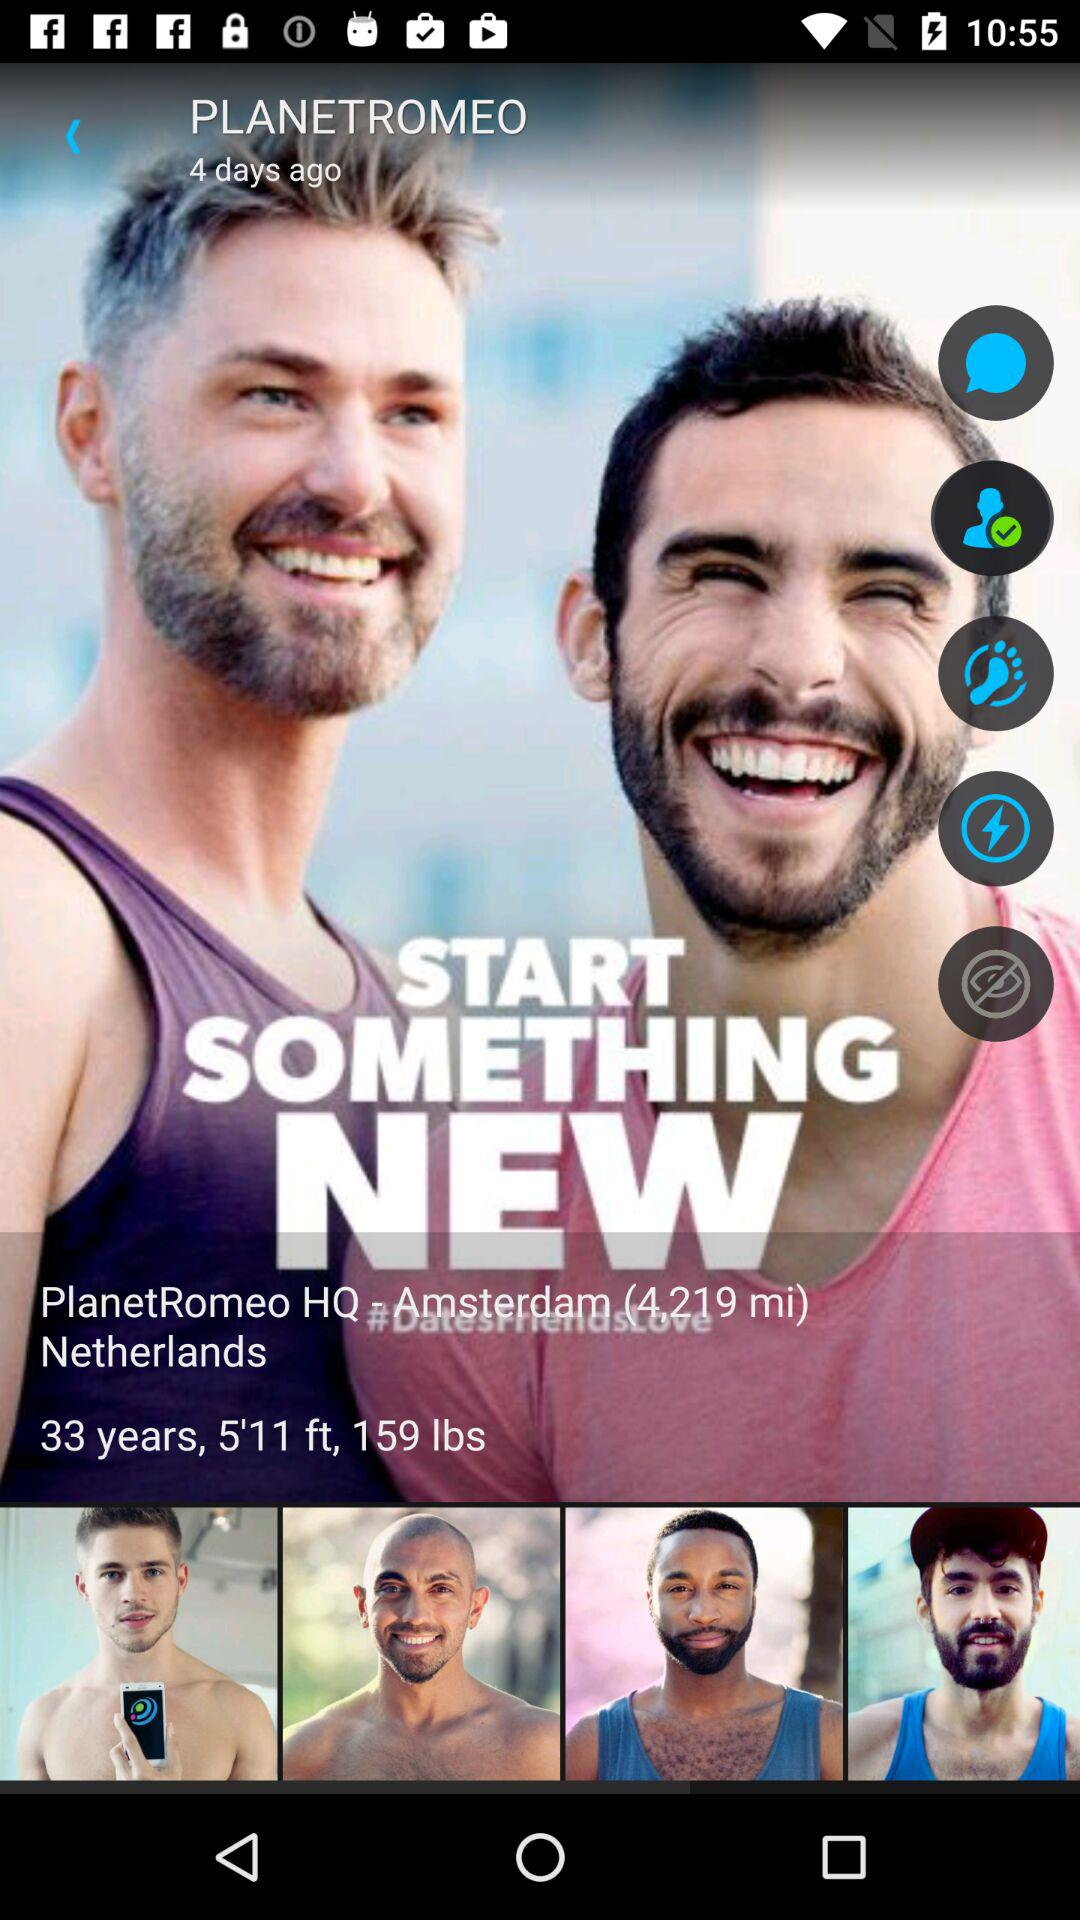When was this post uploaded? This post was uploaded 4 days ago. 